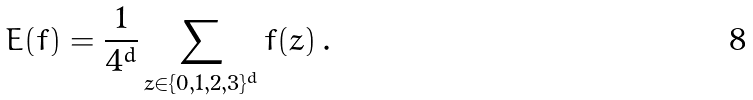<formula> <loc_0><loc_0><loc_500><loc_500>E ( f ) = \frac { 1 } { 4 ^ { d } } \sum _ { z \in \{ 0 , 1 , 2 , 3 \} ^ { d } } f ( z ) \, .</formula> 